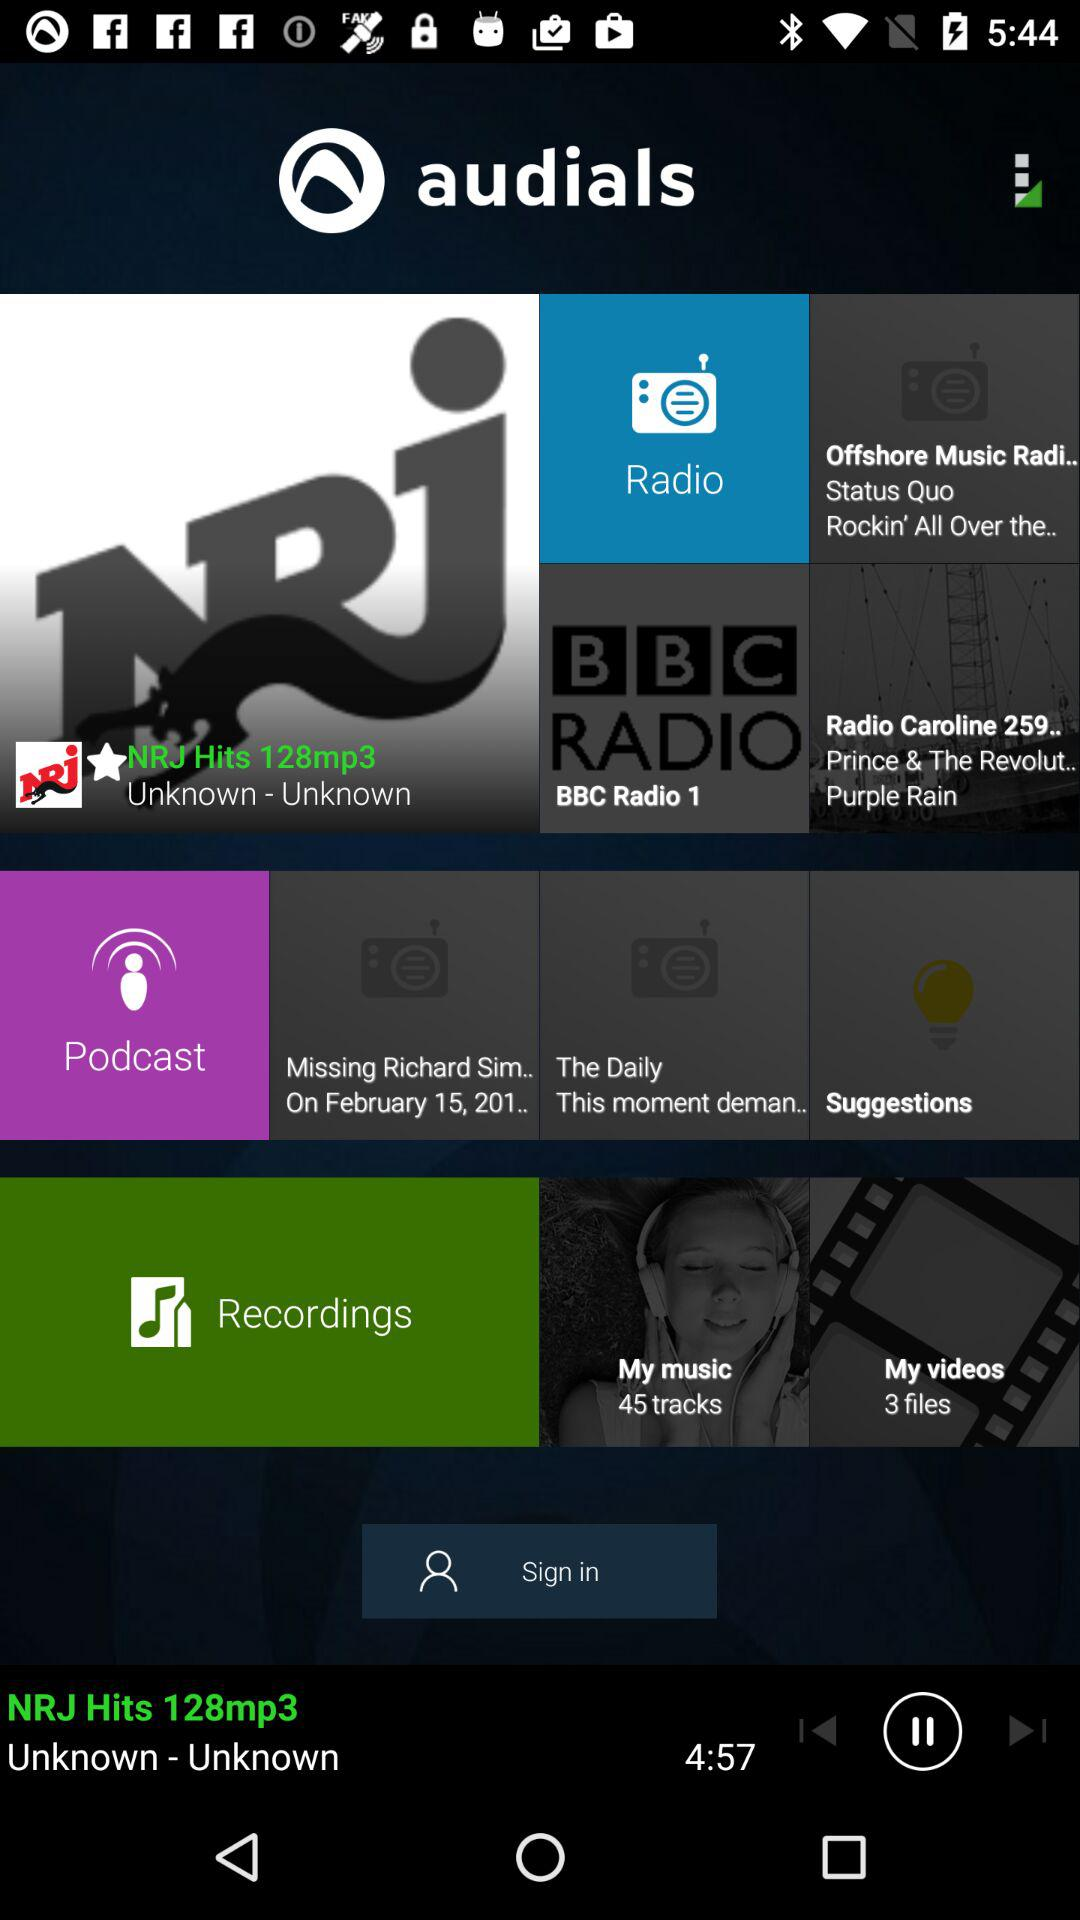What is the duration of the song? The duration of the song is 4 minutes 57 seconds. 